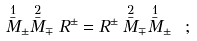Convert formula to latex. <formula><loc_0><loc_0><loc_500><loc_500>\stackrel { 1 } { \bar { M } } _ { \pm } \stackrel { 2 } { \bar { M } } _ { \mp } R ^ { \pm } = R ^ { \pm } \stackrel { 2 } { \bar { M } } _ { \mp } \stackrel { 1 } { \bar { M } } _ { \pm } \ ;</formula> 